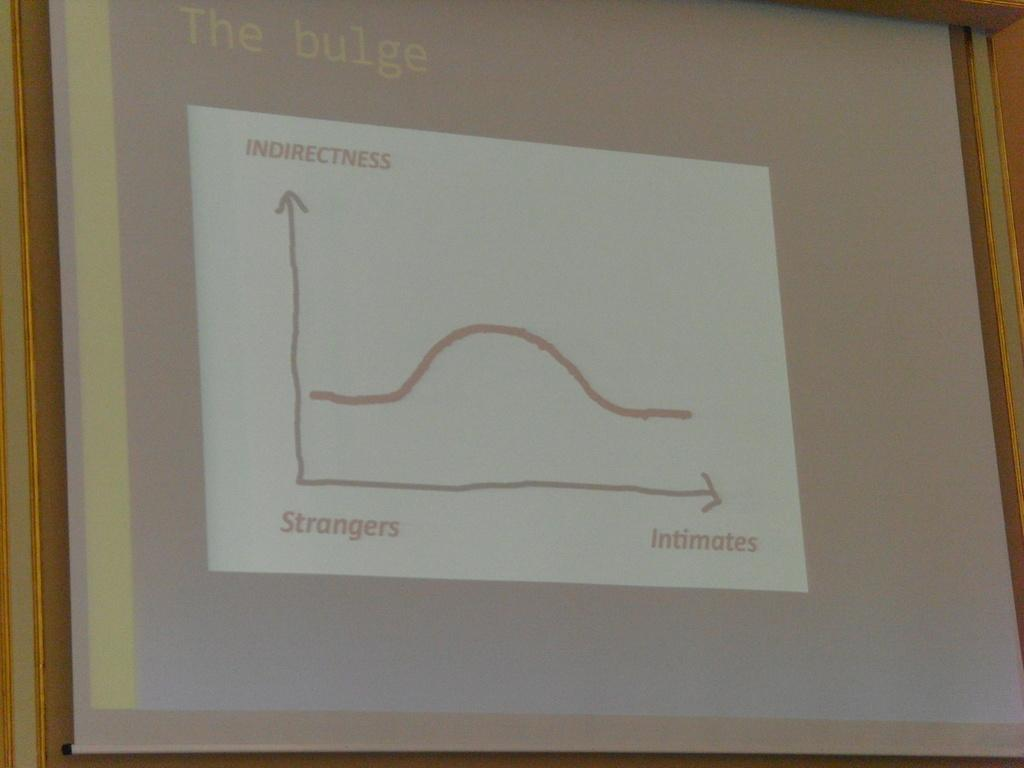<image>
Write a terse but informative summary of the picture. a presentation screen that says 'the bulge' on it 